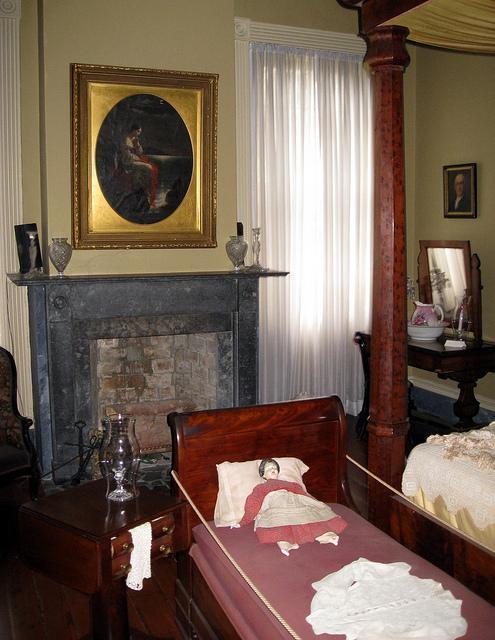What is the black structure against the wall used to contain?
Indicate the correct choice and explain in the format: 'Answer: answer
Rationale: rationale.'
Options: Books, pillows, fire, water. Answer: fire.
Rationale: The black structure against the wall is a fireplace used for making fires. 